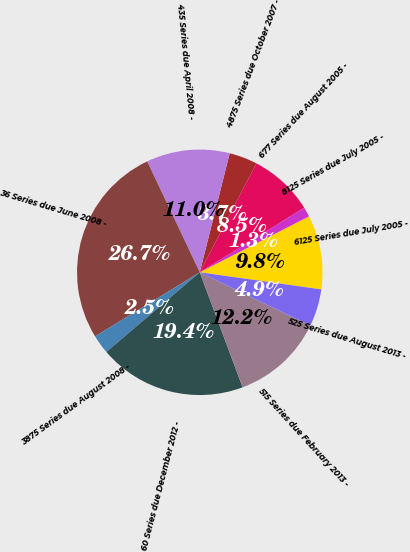Convert chart. <chart><loc_0><loc_0><loc_500><loc_500><pie_chart><fcel>6125 Series due July 2005 -<fcel>8125 Series due July 2005 -<fcel>677 Series due August 2005 -<fcel>4875 Series due October 2007 -<fcel>435 Series due April 2008 -<fcel>36 Series due June 2008 -<fcel>3875 Series due August 2008 -<fcel>60 Series due December 2012 -<fcel>515 Series due February 2013 -<fcel>525 Series due August 2013 -<nl><fcel>9.76%<fcel>1.29%<fcel>8.55%<fcel>3.71%<fcel>10.97%<fcel>26.7%<fcel>2.5%<fcel>19.44%<fcel>12.18%<fcel>4.92%<nl></chart> 